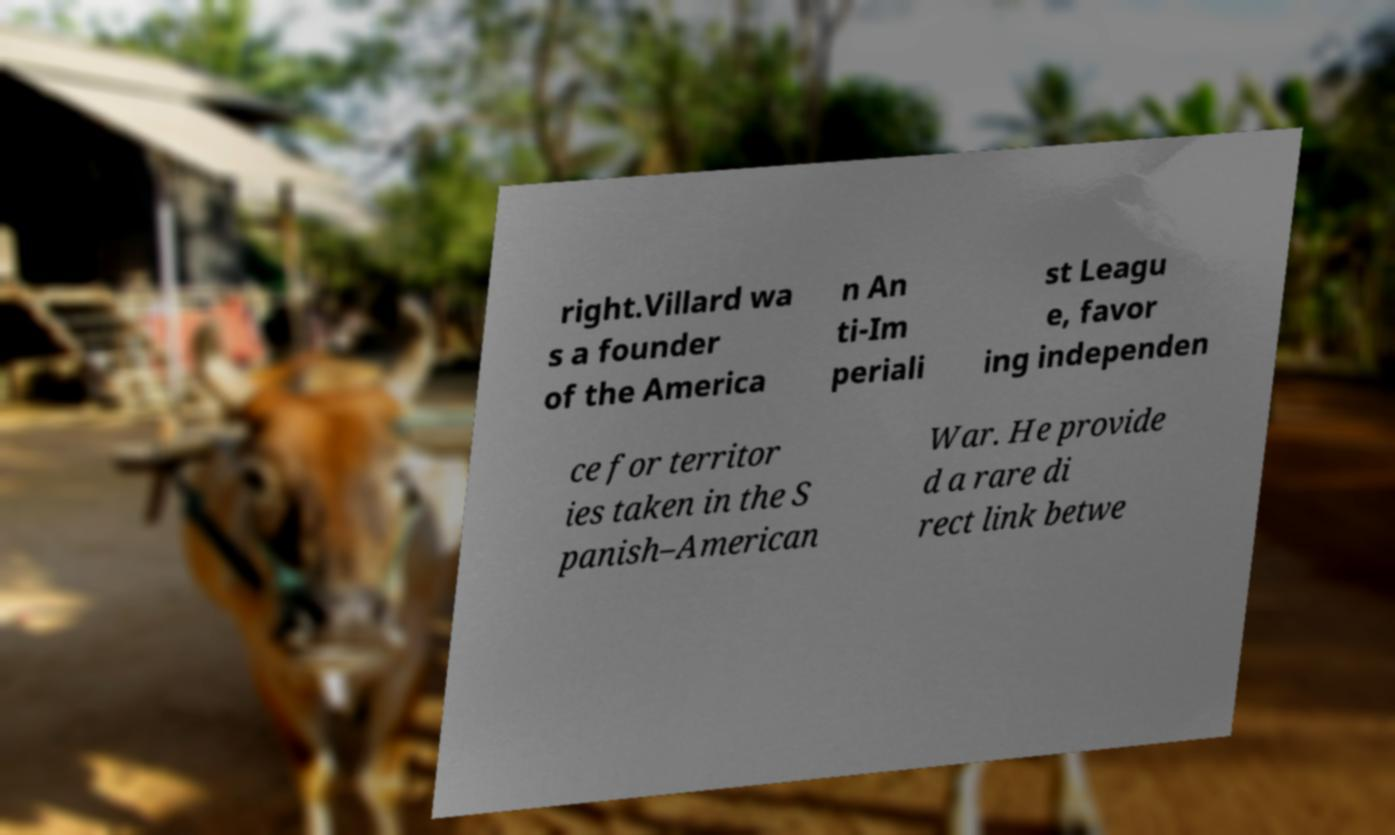Could you extract and type out the text from this image? right.Villard wa s a founder of the America n An ti-Im periali st Leagu e, favor ing independen ce for territor ies taken in the S panish–American War. He provide d a rare di rect link betwe 